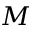<formula> <loc_0><loc_0><loc_500><loc_500>M</formula> 